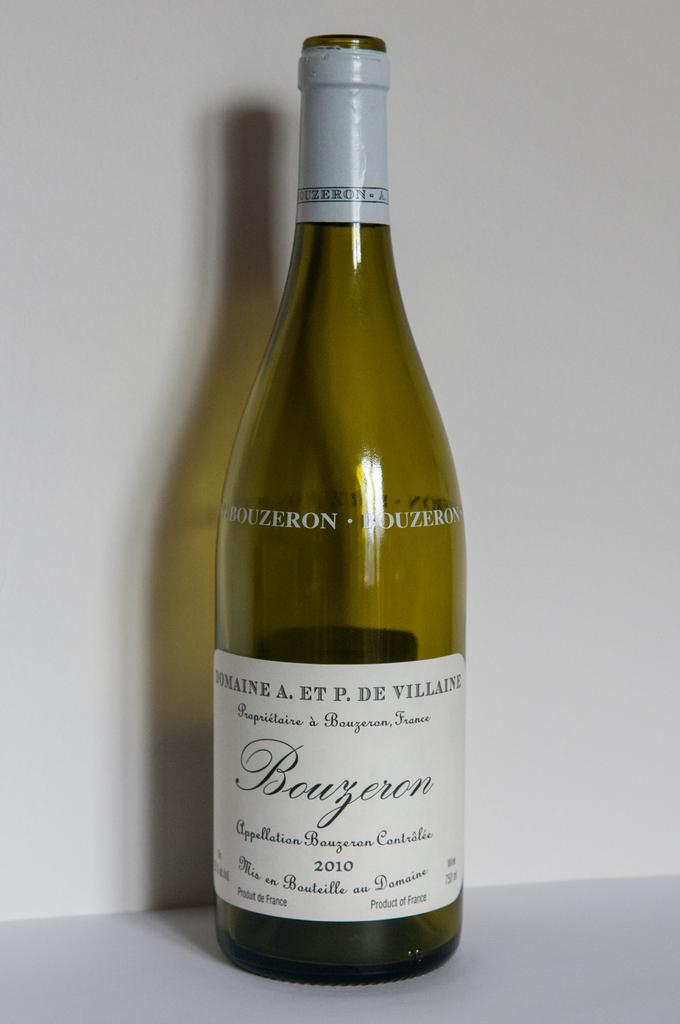<image>
Render a clear and concise summary of the photo. A bottle of wine has a label with Bouzeron on the front in cursive. 